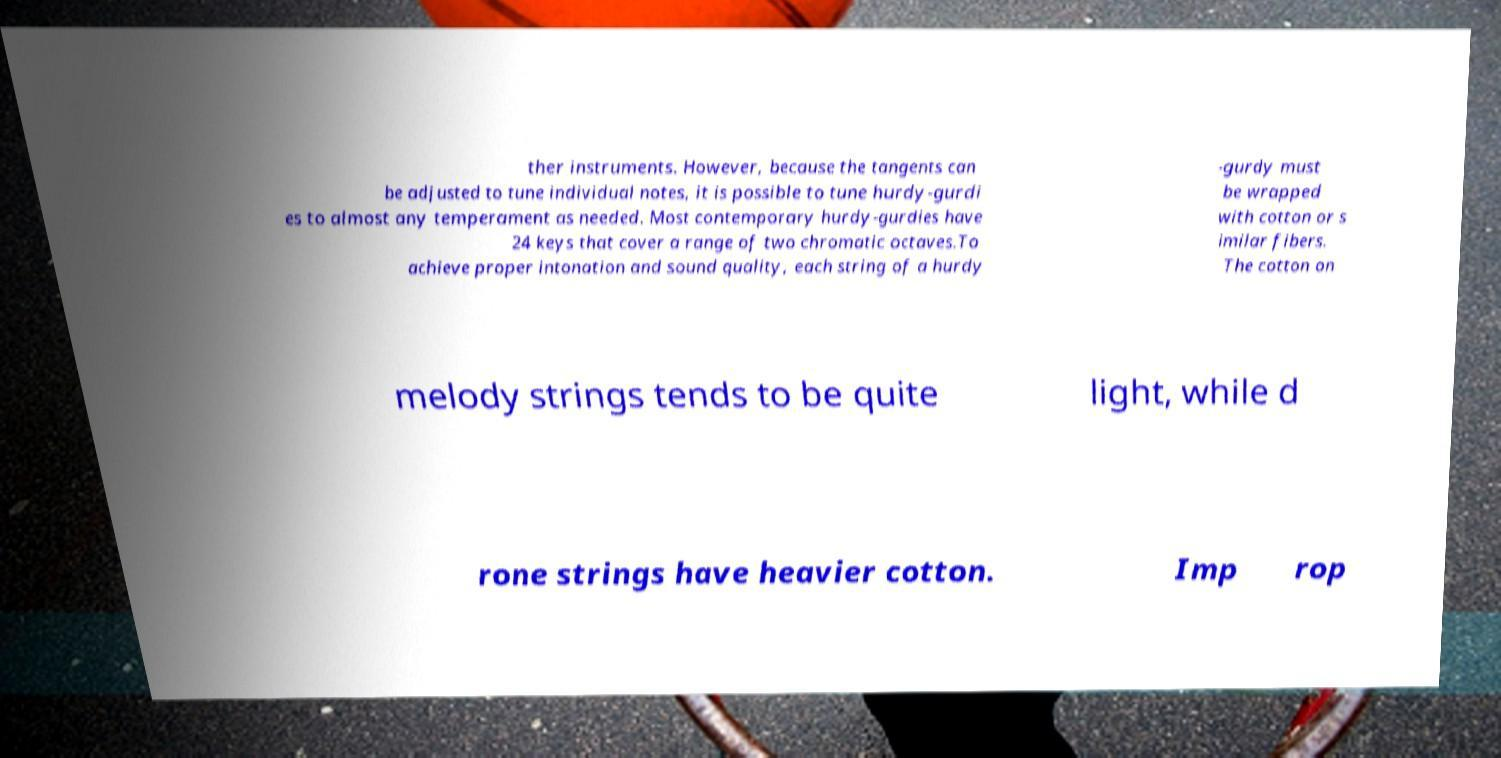For documentation purposes, I need the text within this image transcribed. Could you provide that? ther instruments. However, because the tangents can be adjusted to tune individual notes, it is possible to tune hurdy-gurdi es to almost any temperament as needed. Most contemporary hurdy-gurdies have 24 keys that cover a range of two chromatic octaves.To achieve proper intonation and sound quality, each string of a hurdy -gurdy must be wrapped with cotton or s imilar fibers. The cotton on melody strings tends to be quite light, while d rone strings have heavier cotton. Imp rop 